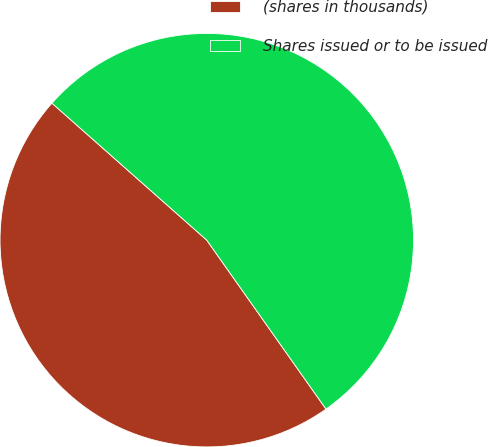<chart> <loc_0><loc_0><loc_500><loc_500><pie_chart><fcel>(shares in thousands)<fcel>Shares issued or to be issued<nl><fcel>46.31%<fcel>53.69%<nl></chart> 